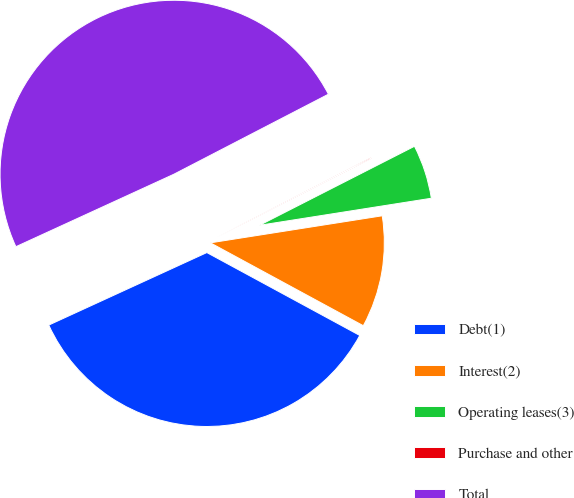Convert chart. <chart><loc_0><loc_0><loc_500><loc_500><pie_chart><fcel>Debt(1)<fcel>Interest(2)<fcel>Operating leases(3)<fcel>Purchase and other<fcel>Total<nl><fcel>35.25%<fcel>10.39%<fcel>5.02%<fcel>0.1%<fcel>49.24%<nl></chart> 